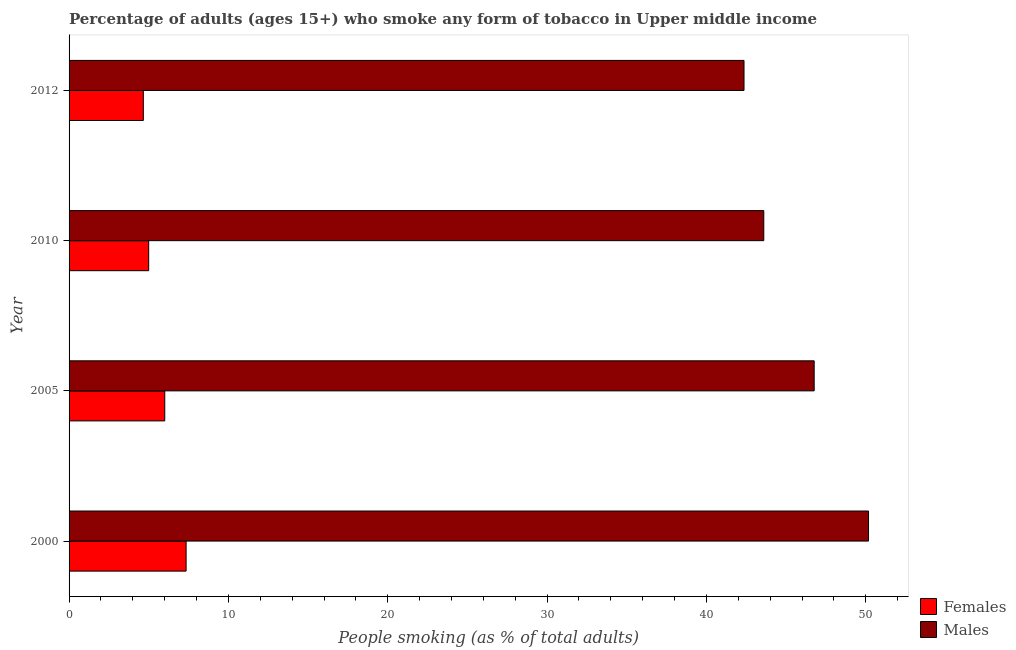Are the number of bars per tick equal to the number of legend labels?
Your answer should be compact. Yes. What is the percentage of males who smoke in 2012?
Provide a short and direct response. 42.36. Across all years, what is the maximum percentage of males who smoke?
Keep it short and to the point. 50.18. Across all years, what is the minimum percentage of males who smoke?
Keep it short and to the point. 42.36. In which year was the percentage of males who smoke maximum?
Keep it short and to the point. 2000. In which year was the percentage of males who smoke minimum?
Make the answer very short. 2012. What is the total percentage of males who smoke in the graph?
Make the answer very short. 182.9. What is the difference between the percentage of females who smoke in 2000 and that in 2005?
Keep it short and to the point. 1.34. What is the difference between the percentage of females who smoke in 2010 and the percentage of males who smoke in 2012?
Keep it short and to the point. -37.36. What is the average percentage of females who smoke per year?
Ensure brevity in your answer.  5.75. In the year 2010, what is the difference between the percentage of females who smoke and percentage of males who smoke?
Give a very brief answer. -38.6. What is the ratio of the percentage of males who smoke in 2000 to that in 2010?
Make the answer very short. 1.15. Is the percentage of females who smoke in 2010 less than that in 2012?
Ensure brevity in your answer.  No. Is the difference between the percentage of females who smoke in 2000 and 2012 greater than the difference between the percentage of males who smoke in 2000 and 2012?
Give a very brief answer. No. What is the difference between the highest and the second highest percentage of females who smoke?
Offer a very short reply. 1.34. What is the difference between the highest and the lowest percentage of males who smoke?
Provide a succinct answer. 7.81. Is the sum of the percentage of males who smoke in 2000 and 2005 greater than the maximum percentage of females who smoke across all years?
Offer a very short reply. Yes. What does the 1st bar from the top in 2010 represents?
Provide a succinct answer. Males. What does the 1st bar from the bottom in 2012 represents?
Keep it short and to the point. Females. How many bars are there?
Offer a terse response. 8. What is the difference between two consecutive major ticks on the X-axis?
Your answer should be compact. 10. Are the values on the major ticks of X-axis written in scientific E-notation?
Your answer should be very brief. No. Does the graph contain grids?
Offer a very short reply. No. How are the legend labels stacked?
Offer a terse response. Vertical. What is the title of the graph?
Your answer should be very brief. Percentage of adults (ages 15+) who smoke any form of tobacco in Upper middle income. Does "Current education expenditure" appear as one of the legend labels in the graph?
Offer a very short reply. No. What is the label or title of the X-axis?
Your answer should be compact. People smoking (as % of total adults). What is the People smoking (as % of total adults) of Females in 2000?
Give a very brief answer. 7.35. What is the People smoking (as % of total adults) of Males in 2000?
Your answer should be compact. 50.18. What is the People smoking (as % of total adults) in Females in 2005?
Offer a terse response. 6.01. What is the People smoking (as % of total adults) in Males in 2005?
Provide a short and direct response. 46.76. What is the People smoking (as % of total adults) of Females in 2010?
Your response must be concise. 5. What is the People smoking (as % of total adults) in Males in 2010?
Ensure brevity in your answer.  43.6. What is the People smoking (as % of total adults) in Females in 2012?
Provide a succinct answer. 4.66. What is the People smoking (as % of total adults) of Males in 2012?
Offer a terse response. 42.36. Across all years, what is the maximum People smoking (as % of total adults) of Females?
Provide a succinct answer. 7.35. Across all years, what is the maximum People smoking (as % of total adults) of Males?
Give a very brief answer. 50.18. Across all years, what is the minimum People smoking (as % of total adults) of Females?
Offer a terse response. 4.66. Across all years, what is the minimum People smoking (as % of total adults) of Males?
Offer a terse response. 42.36. What is the total People smoking (as % of total adults) in Females in the graph?
Offer a very short reply. 23.01. What is the total People smoking (as % of total adults) of Males in the graph?
Give a very brief answer. 182.9. What is the difference between the People smoking (as % of total adults) of Females in 2000 and that in 2005?
Your answer should be very brief. 1.34. What is the difference between the People smoking (as % of total adults) in Males in 2000 and that in 2005?
Make the answer very short. 3.41. What is the difference between the People smoking (as % of total adults) in Females in 2000 and that in 2010?
Provide a short and direct response. 2.35. What is the difference between the People smoking (as % of total adults) in Males in 2000 and that in 2010?
Provide a succinct answer. 6.57. What is the difference between the People smoking (as % of total adults) in Females in 2000 and that in 2012?
Keep it short and to the point. 2.68. What is the difference between the People smoking (as % of total adults) in Males in 2000 and that in 2012?
Provide a short and direct response. 7.81. What is the difference between the People smoking (as % of total adults) of Females in 2005 and that in 2010?
Make the answer very short. 1.01. What is the difference between the People smoking (as % of total adults) of Males in 2005 and that in 2010?
Give a very brief answer. 3.16. What is the difference between the People smoking (as % of total adults) in Females in 2005 and that in 2012?
Give a very brief answer. 1.34. What is the difference between the People smoking (as % of total adults) in Males in 2005 and that in 2012?
Your answer should be compact. 4.4. What is the difference between the People smoking (as % of total adults) in Females in 2010 and that in 2012?
Keep it short and to the point. 0.34. What is the difference between the People smoking (as % of total adults) in Males in 2010 and that in 2012?
Provide a succinct answer. 1.24. What is the difference between the People smoking (as % of total adults) of Females in 2000 and the People smoking (as % of total adults) of Males in 2005?
Offer a very short reply. -39.42. What is the difference between the People smoking (as % of total adults) of Females in 2000 and the People smoking (as % of total adults) of Males in 2010?
Your answer should be compact. -36.26. What is the difference between the People smoking (as % of total adults) in Females in 2000 and the People smoking (as % of total adults) in Males in 2012?
Your response must be concise. -35.02. What is the difference between the People smoking (as % of total adults) of Females in 2005 and the People smoking (as % of total adults) of Males in 2010?
Make the answer very short. -37.6. What is the difference between the People smoking (as % of total adults) in Females in 2005 and the People smoking (as % of total adults) in Males in 2012?
Keep it short and to the point. -36.36. What is the difference between the People smoking (as % of total adults) of Females in 2010 and the People smoking (as % of total adults) of Males in 2012?
Offer a terse response. -37.36. What is the average People smoking (as % of total adults) of Females per year?
Make the answer very short. 5.75. What is the average People smoking (as % of total adults) in Males per year?
Keep it short and to the point. 45.73. In the year 2000, what is the difference between the People smoking (as % of total adults) in Females and People smoking (as % of total adults) in Males?
Keep it short and to the point. -42.83. In the year 2005, what is the difference between the People smoking (as % of total adults) of Females and People smoking (as % of total adults) of Males?
Provide a succinct answer. -40.76. In the year 2010, what is the difference between the People smoking (as % of total adults) of Females and People smoking (as % of total adults) of Males?
Offer a terse response. -38.6. In the year 2012, what is the difference between the People smoking (as % of total adults) in Females and People smoking (as % of total adults) in Males?
Offer a terse response. -37.7. What is the ratio of the People smoking (as % of total adults) of Females in 2000 to that in 2005?
Provide a succinct answer. 1.22. What is the ratio of the People smoking (as % of total adults) of Males in 2000 to that in 2005?
Offer a terse response. 1.07. What is the ratio of the People smoking (as % of total adults) in Females in 2000 to that in 2010?
Ensure brevity in your answer.  1.47. What is the ratio of the People smoking (as % of total adults) in Males in 2000 to that in 2010?
Offer a very short reply. 1.15. What is the ratio of the People smoking (as % of total adults) in Females in 2000 to that in 2012?
Your response must be concise. 1.58. What is the ratio of the People smoking (as % of total adults) of Males in 2000 to that in 2012?
Provide a succinct answer. 1.18. What is the ratio of the People smoking (as % of total adults) of Females in 2005 to that in 2010?
Your response must be concise. 1.2. What is the ratio of the People smoking (as % of total adults) in Males in 2005 to that in 2010?
Your answer should be compact. 1.07. What is the ratio of the People smoking (as % of total adults) in Females in 2005 to that in 2012?
Give a very brief answer. 1.29. What is the ratio of the People smoking (as % of total adults) in Males in 2005 to that in 2012?
Your answer should be compact. 1.1. What is the ratio of the People smoking (as % of total adults) of Females in 2010 to that in 2012?
Offer a very short reply. 1.07. What is the ratio of the People smoking (as % of total adults) in Males in 2010 to that in 2012?
Offer a terse response. 1.03. What is the difference between the highest and the second highest People smoking (as % of total adults) of Females?
Ensure brevity in your answer.  1.34. What is the difference between the highest and the second highest People smoking (as % of total adults) in Males?
Your answer should be compact. 3.41. What is the difference between the highest and the lowest People smoking (as % of total adults) in Females?
Ensure brevity in your answer.  2.68. What is the difference between the highest and the lowest People smoking (as % of total adults) in Males?
Provide a short and direct response. 7.81. 